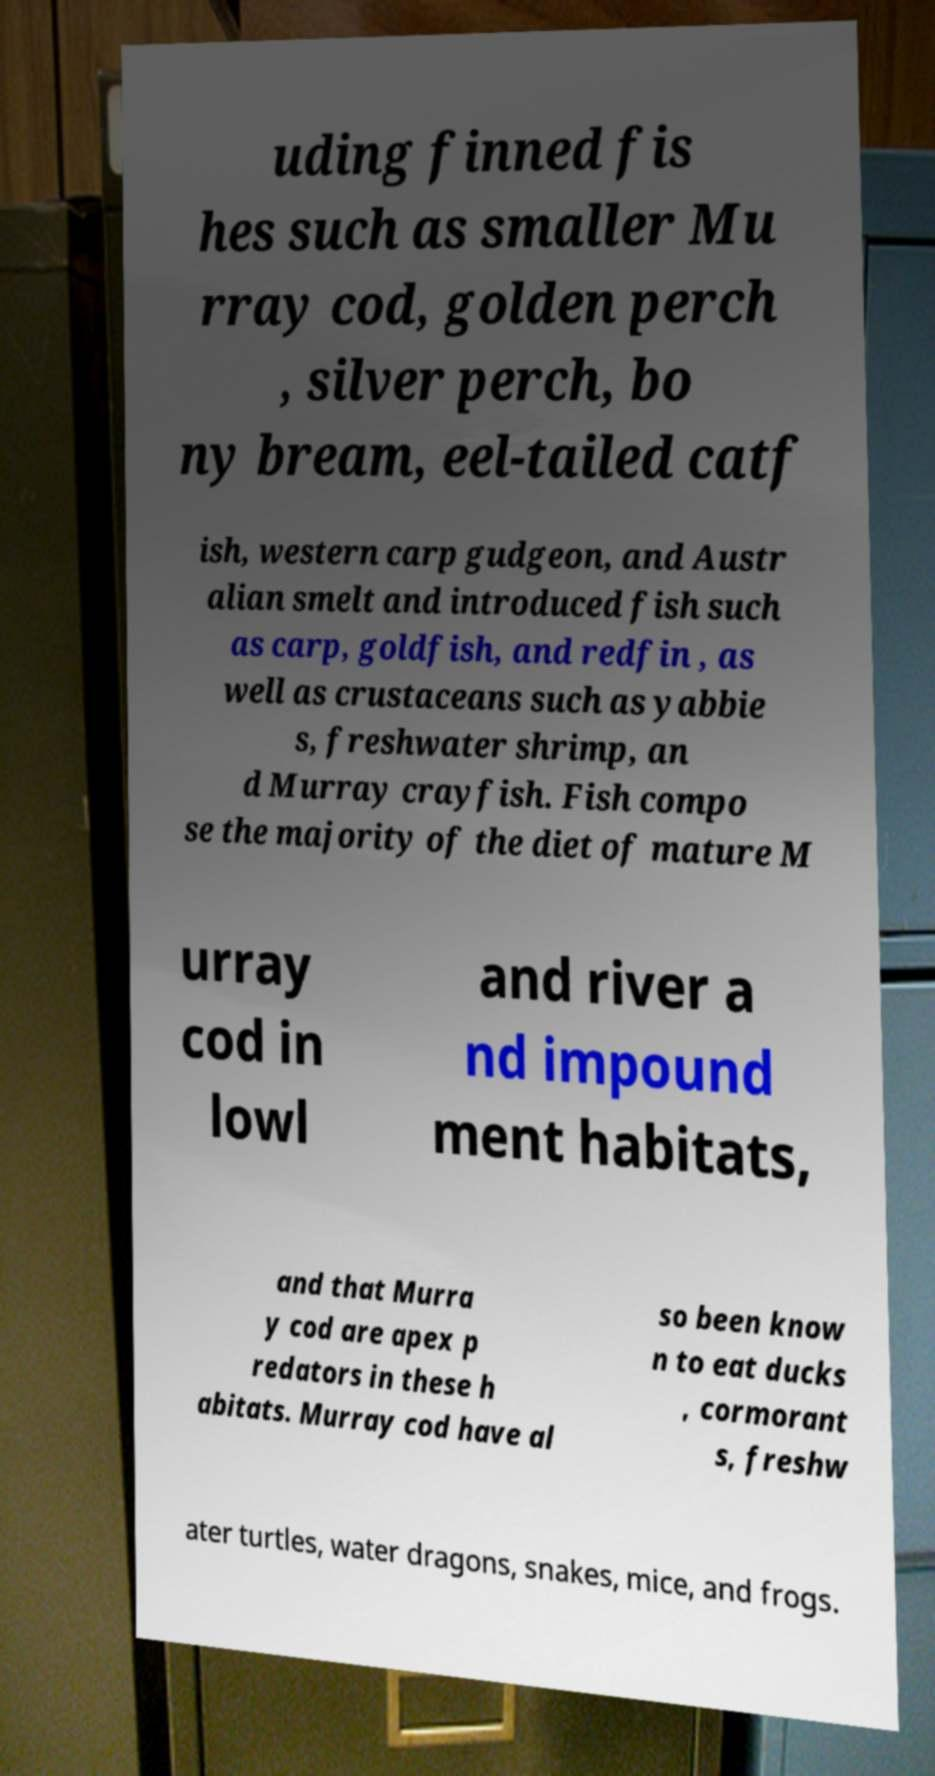Please read and relay the text visible in this image. What does it say? uding finned fis hes such as smaller Mu rray cod, golden perch , silver perch, bo ny bream, eel-tailed catf ish, western carp gudgeon, and Austr alian smelt and introduced fish such as carp, goldfish, and redfin , as well as crustaceans such as yabbie s, freshwater shrimp, an d Murray crayfish. Fish compo se the majority of the diet of mature M urray cod in lowl and river a nd impound ment habitats, and that Murra y cod are apex p redators in these h abitats. Murray cod have al so been know n to eat ducks , cormorant s, freshw ater turtles, water dragons, snakes, mice, and frogs. 